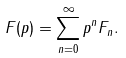<formula> <loc_0><loc_0><loc_500><loc_500>F ( p ) = \sum _ { n = 0 } ^ { \infty } p ^ { n } F _ { n } .</formula> 